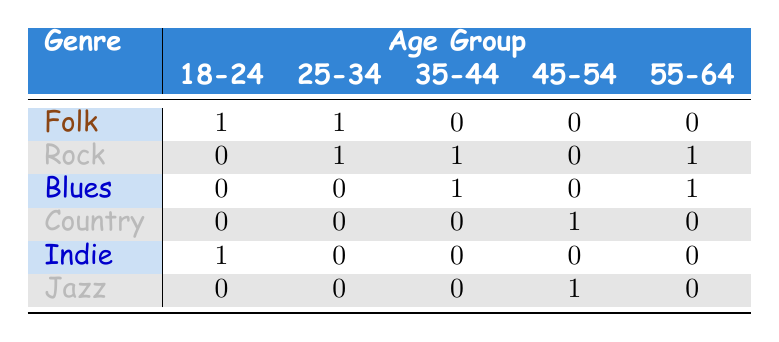What is the most preferred genre among listeners aged 18-24? In the table, for the age group 18-24, the only preferred genre is Folk, as indicated by the value '1' in that corresponding cell.
Answer: Folk How many listeners aged 55-64 prefer Rock? Looking at the 55-64 age group, there is one listener who prefers Rock, which is shown by the value '1' in that cell.
Answer: 1 What percentage of listeners aged 25-34 prefer Folk? There are two listeners in the 25-34 age group (one prefers Folk and one prefers Rock). Thus, the percentage who prefer Folk is (1/2) * 100 = 50%.
Answer: 50% Is there a listener aged 45-54 who prefers Jazz? The table shows that there is one listener aged 45-54 who prefers Jazz, as indicated by the value '1' in that cell.
Answer: Yes What is the total number of listeners who prefer the Blues across all age groups? Adding up the values in the Blues row across all age groups gives (0 + 0 + 1 + 0 + 1) = 2.
Answer: 2 Among listeners aged 35-44, which genre is least preferred? For the age group 35-44, the genres listed are Blues (1) and Rock (1). So, since no other genres are represented, the least preferred is Jazz, as it has a value of '0' in that row.
Answer: Jazz How many listeners prefer Folk compared to the total number of listeners aged 45-54? There is 1 listener who prefers Folk, while there are 2 listeners total aged 45-54 (Country and Jazz). Thus, we have 1 Folk listener compared to 2 total, giving a ratio of 1:2.
Answer: 1:2 What is the most popular genre overall? The table shows the total counts for each genre: Folk (2), Rock (3), Blues (2), Country (1), Indie (1), Jazz (1). The maximum count is for Rock with 3 listeners.
Answer: Rock 